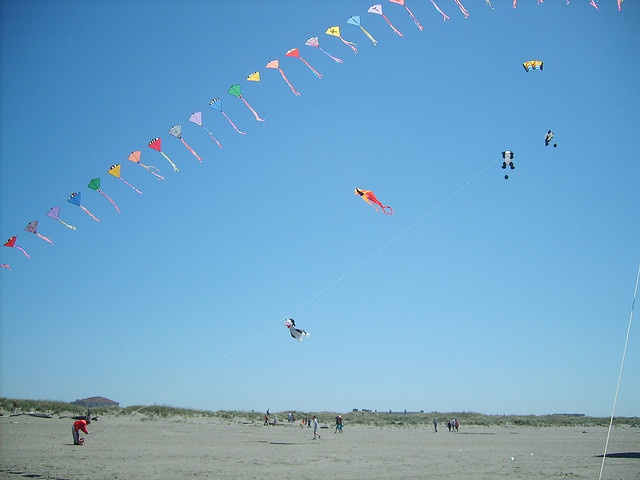Describe the objects in this image and their specific colors. I can see kite in blue, darkgray, and gray tones, people in blue, gray, darkgray, and black tones, kite in blue, salmon, darkgray, and gray tones, kite in blue, darkgray, salmon, lightblue, and lightpink tones, and kite in blue, lightblue, gray, and darkgray tones in this image. 